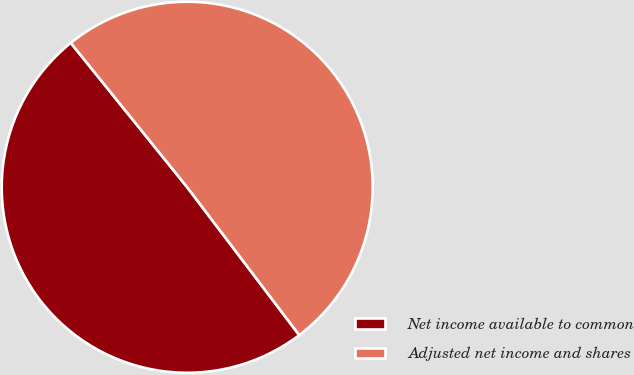Convert chart. <chart><loc_0><loc_0><loc_500><loc_500><pie_chart><fcel>Net income available to common<fcel>Adjusted net income and shares<nl><fcel>49.52%<fcel>50.48%<nl></chart> 